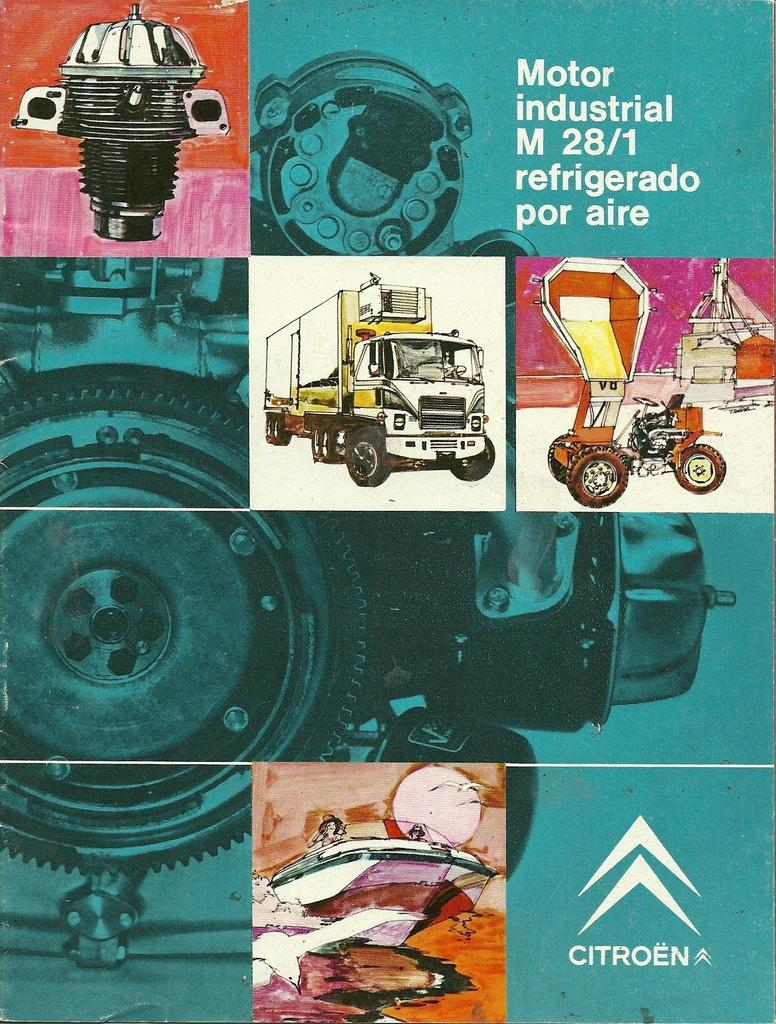What type of page is depicted in the image? The image is a cover page. What can be seen on the cover page? There are paintings on the cover page. What effect does the elbow have on the paintings in the image? There is no mention of an elbow in the image, and therefore no such effect can be observed. What type of maid is depicted in the painting on the cover page? There is no mention of a maid in the image, as it only features paintings on the cover page. 